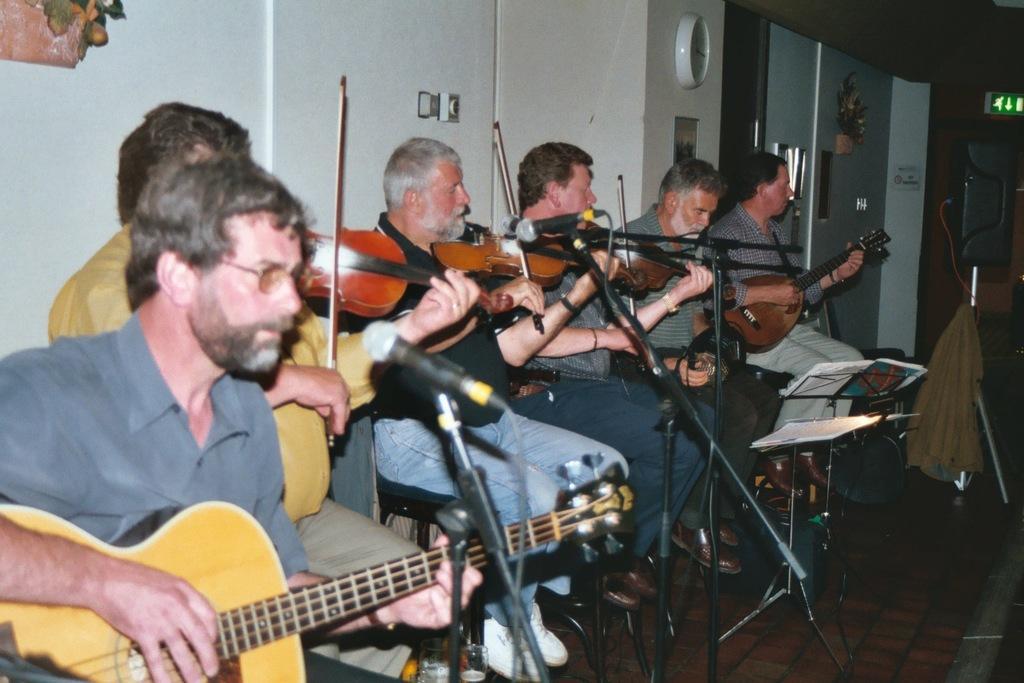In one or two sentences, can you explain what this image depicts? In this image i can see six man sitting and playing a guitar, there are two micro phones in front of them, there is a stand and two books on the stand, these men are wearing, ash, yellow, and black t-shirts at the back ground i can see a white wall and clock attached to it at right there is a cloth and a stand. 